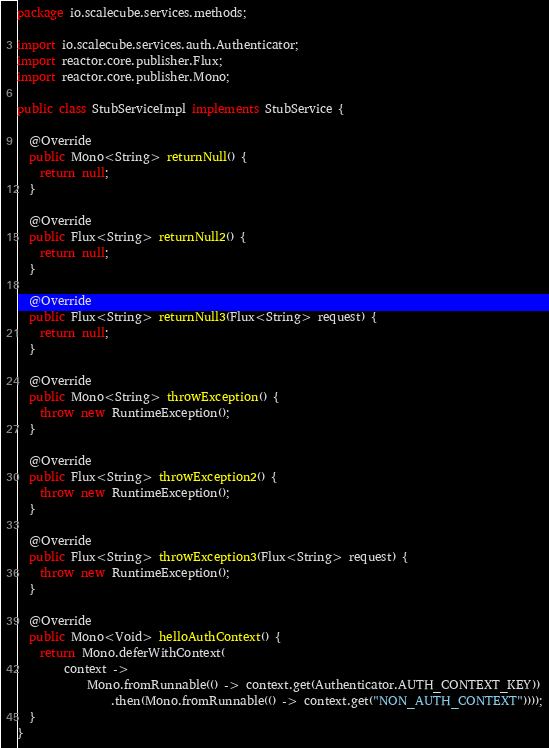<code> <loc_0><loc_0><loc_500><loc_500><_Java_>package io.scalecube.services.methods;

import io.scalecube.services.auth.Authenticator;
import reactor.core.publisher.Flux;
import reactor.core.publisher.Mono;

public class StubServiceImpl implements StubService {

  @Override
  public Mono<String> returnNull() {
    return null;
  }

  @Override
  public Flux<String> returnNull2() {
    return null;
  }

  @Override
  public Flux<String> returnNull3(Flux<String> request) {
    return null;
  }

  @Override
  public Mono<String> throwException() {
    throw new RuntimeException();
  }

  @Override
  public Flux<String> throwException2() {
    throw new RuntimeException();
  }

  @Override
  public Flux<String> throwException3(Flux<String> request) {
    throw new RuntimeException();
  }

  @Override
  public Mono<Void> helloAuthContext() {
    return Mono.deferWithContext(
        context ->
            Mono.fromRunnable(() -> context.get(Authenticator.AUTH_CONTEXT_KEY))
                .then(Mono.fromRunnable(() -> context.get("NON_AUTH_CONTEXT"))));
  }
}
</code> 